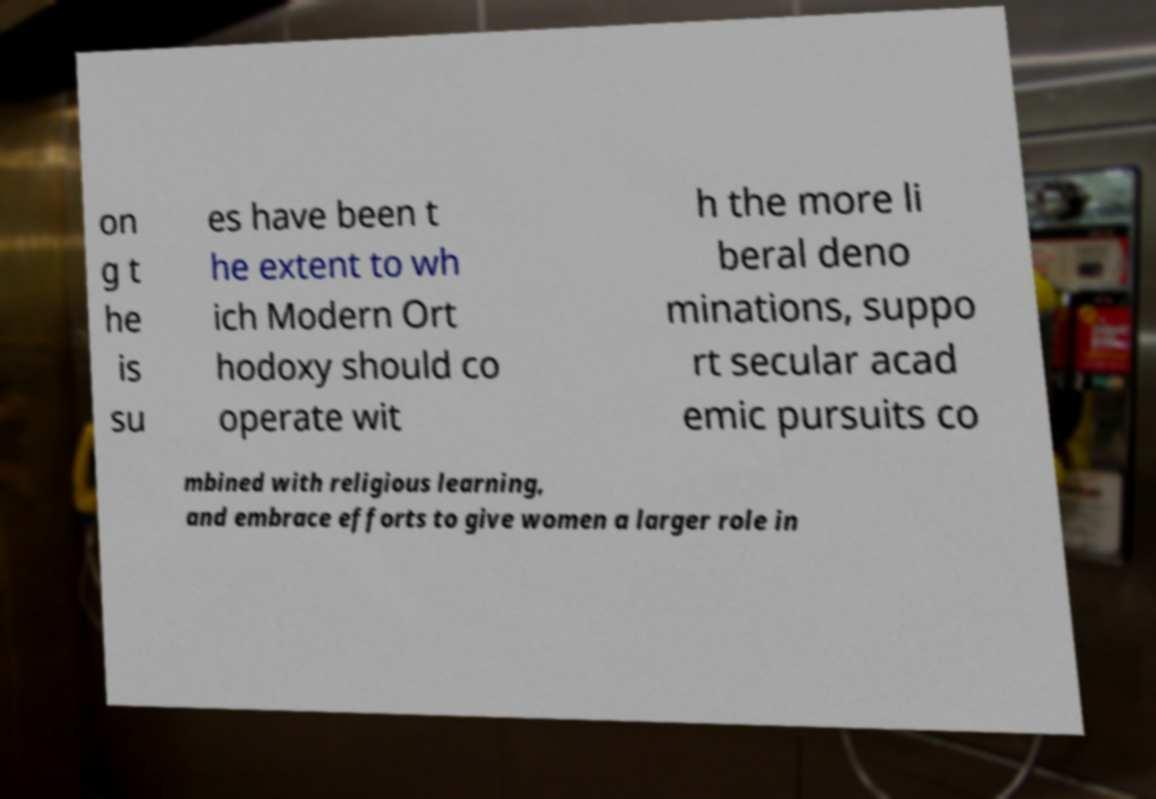Can you read and provide the text displayed in the image?This photo seems to have some interesting text. Can you extract and type it out for me? on g t he is su es have been t he extent to wh ich Modern Ort hodoxy should co operate wit h the more li beral deno minations, suppo rt secular acad emic pursuits co mbined with religious learning, and embrace efforts to give women a larger role in 